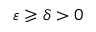Convert formula to latex. <formula><loc_0><loc_0><loc_500><loc_500>\varepsilon \geqslant \delta > 0</formula> 